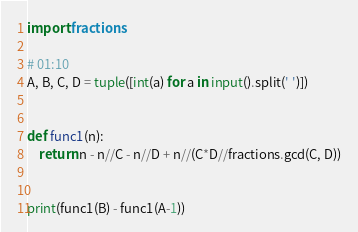Convert code to text. <code><loc_0><loc_0><loc_500><loc_500><_Python_>import fractions 

# 01:10
A, B, C, D = tuple([int(a) for a in input().split(' ')])


def func1(n):
    return n - n//C - n//D + n//(C*D//fractions.gcd(C, D))


print(func1(B) - func1(A-1))
</code> 